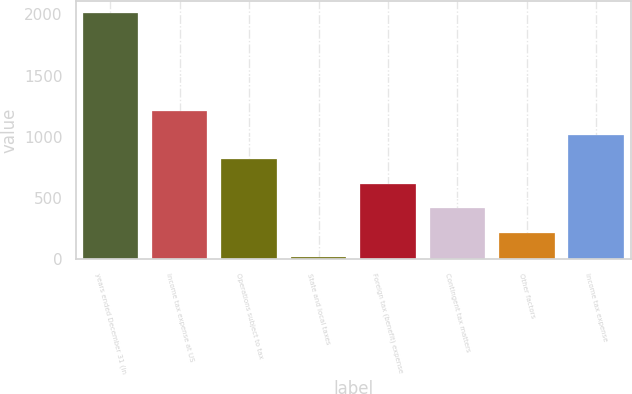Convert chart. <chart><loc_0><loc_0><loc_500><loc_500><bar_chart><fcel>years ended December 31 (in<fcel>Income tax expense at US<fcel>Operations subject to tax<fcel>State and local taxes<fcel>Foreign tax (benefit) expense<fcel>Contingent tax matters<fcel>Other factors<fcel>Income tax expense<nl><fcel>2010<fcel>1213.2<fcel>814.8<fcel>18<fcel>615.6<fcel>416.4<fcel>217.2<fcel>1014<nl></chart> 